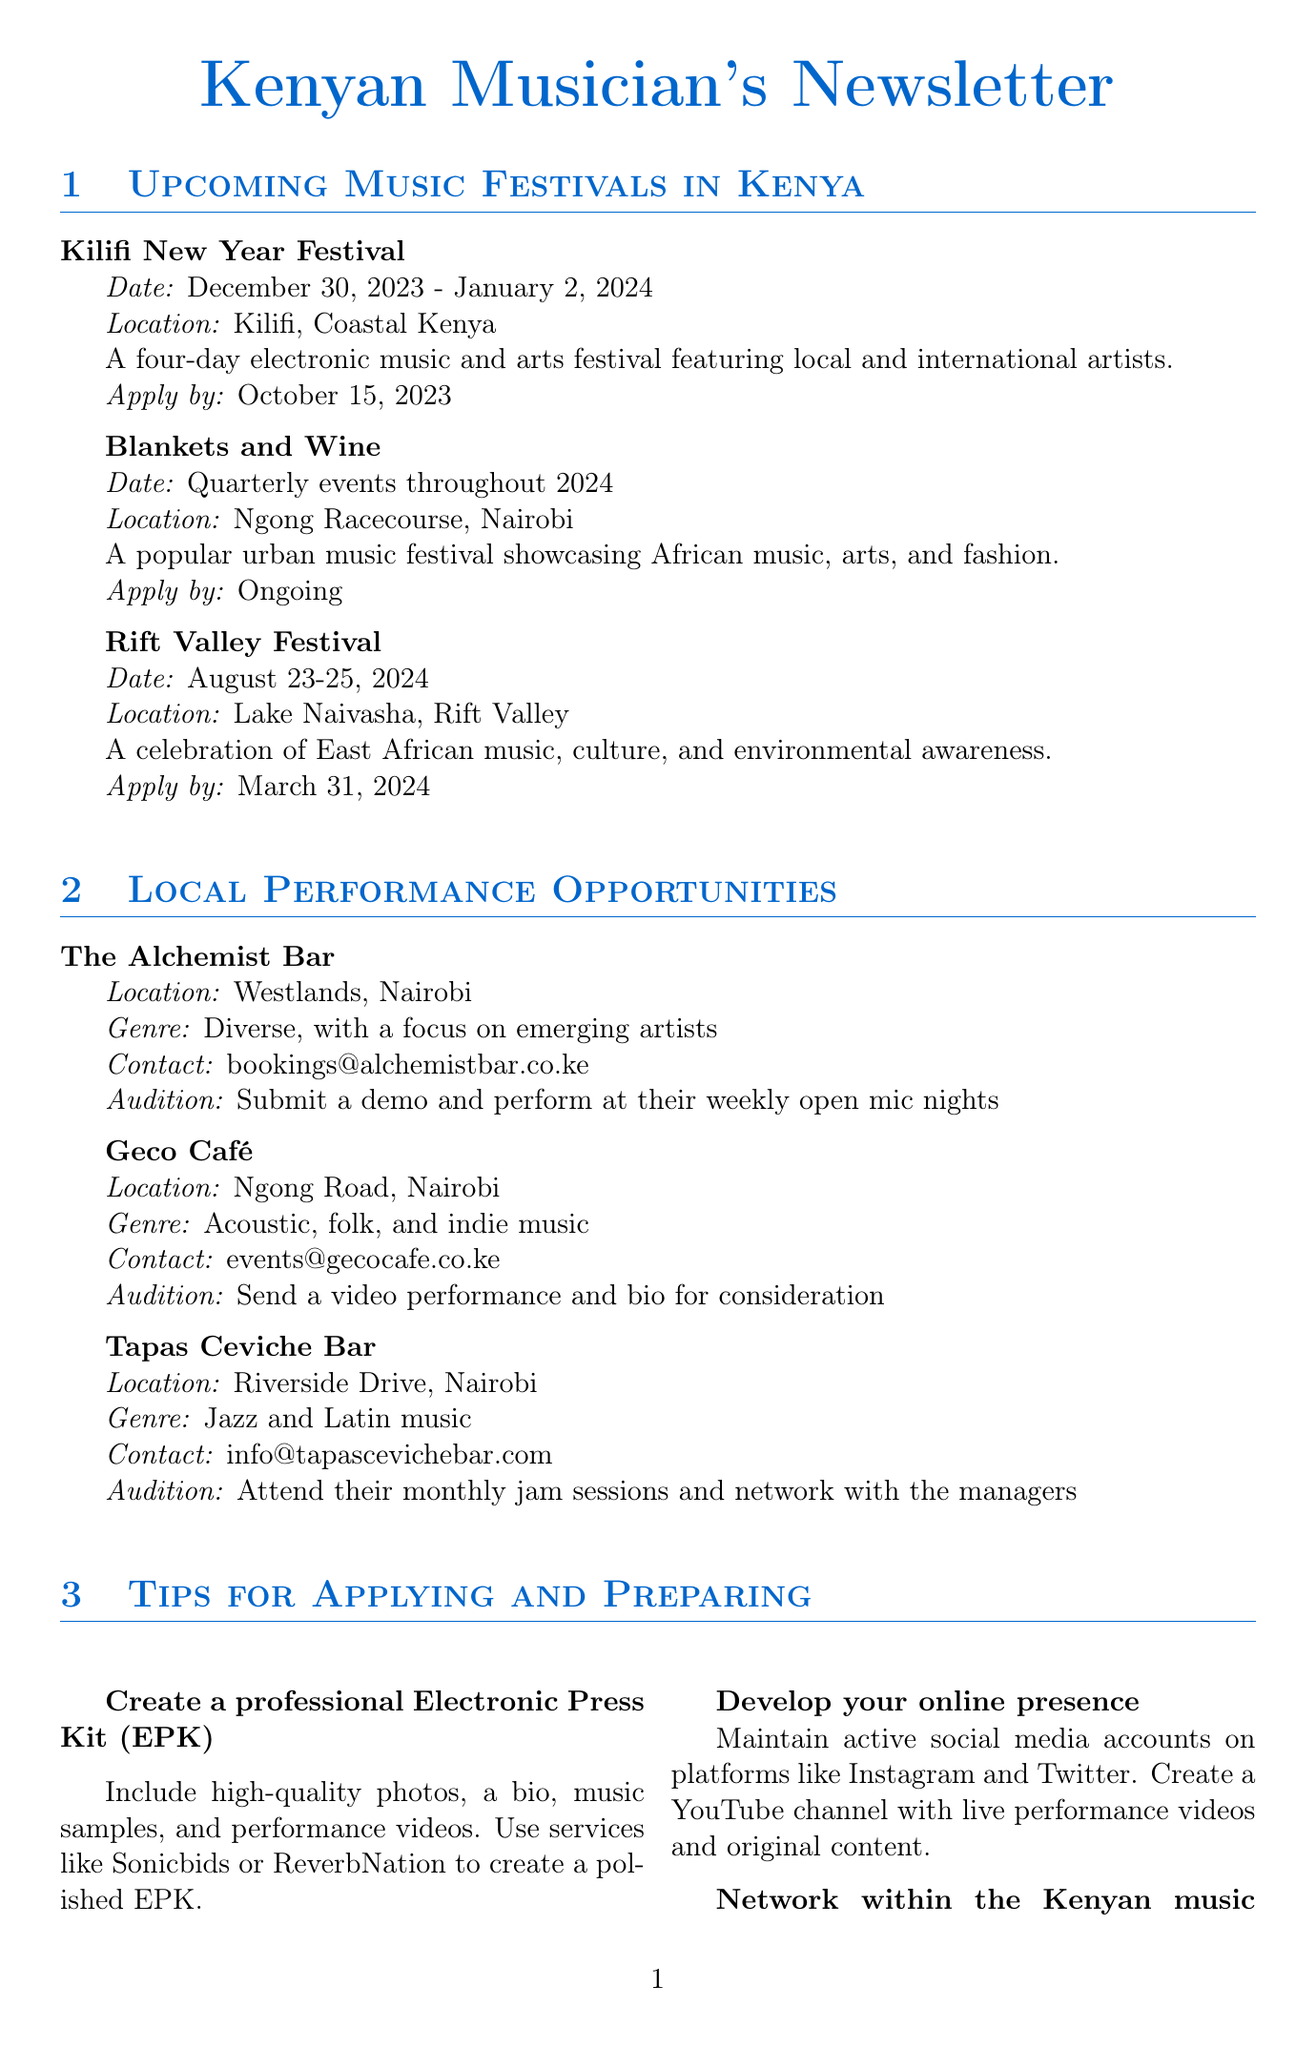what is the date of the Kilifi New Year Festival? The date is mentioned in the section about music festivals, specifically for the Kilifi New Year Festival.
Answer: December 30, 2023 - January 2, 2024 where is the Blankets and Wine festival held? The location is provided in the festival section for Blankets and Wine.
Answer: Ngong Racecourse, Nairobi when is the application deadline for the Rift Valley Festival? The document states the application deadline listed for the Rift Valley Festival.
Answer: March 31, 2024 what is the genre focus of Geco Café? The genre focus is indicated in the local performance opportunities section for Geco Café.
Answer: Acoustic, folk, and indie music what is one tip for musicians to prepare for applications? This inquiry seeks specific advice provided in the tips section of the newsletter.
Answer: Create a professional Electronic Press Kit (EPK) which organization offers loans for creative entrepreneurs in East Africa? The answer can be found in the funding opportunities section where HEVA Fund is mentioned.
Answer: HEVA Fund how often are auditions announced for the Safaricom Blaze BYOB TV Show? This is detailed in the funding opportunities section regarding the Safaricom Blaze BYOB TV Show.
Answer: Annual what is required to audition at The Alchemist Bar? The audition process for The Alchemist Bar is specifically stated in the local performance opportunities section.
Answer: Submit a demo and perform at their weekly open mic nights which platform is suggested for creating a professional EPK? The tip section mentions services suitable for creating an EPK and highlights one specific type.
Answer: Sonicbids or ReverbNation 